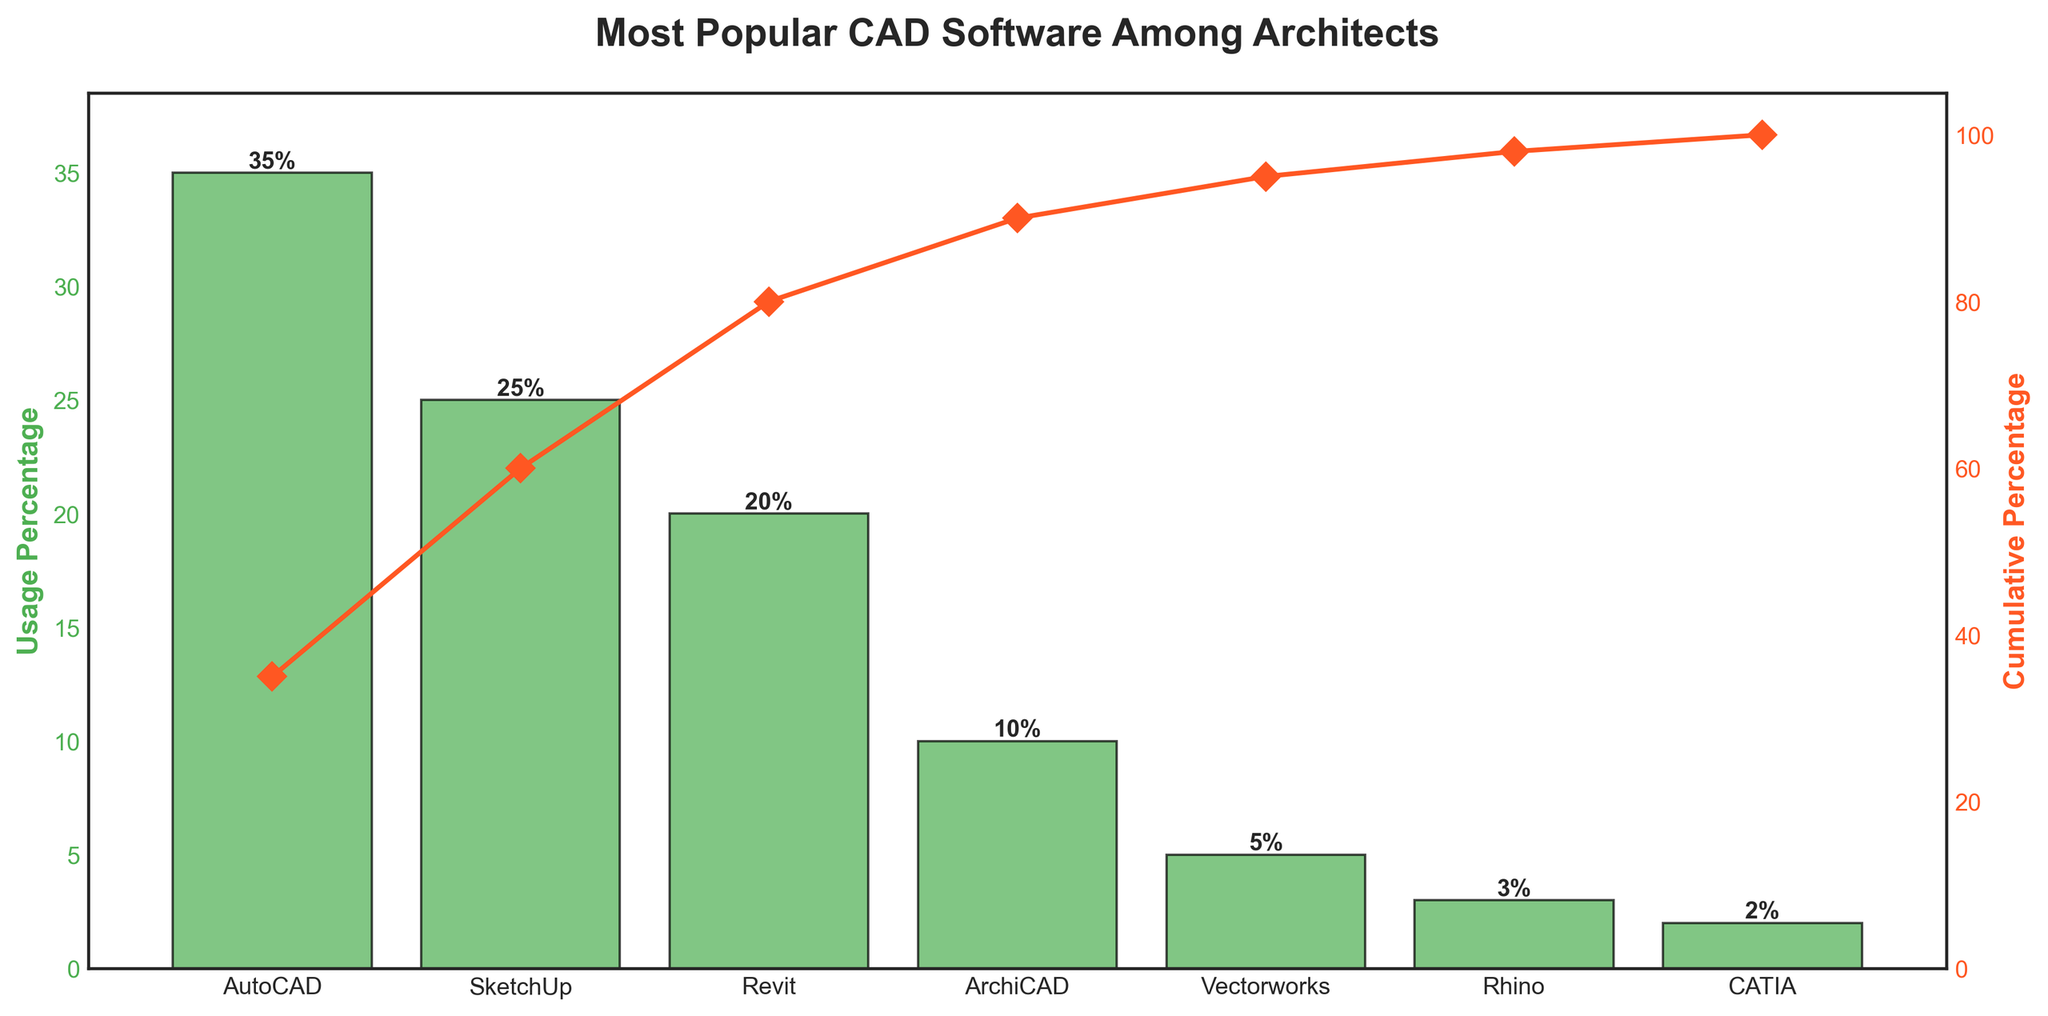what is the most popular CAD software among architects? The figure shows a Pareto chart titled 'Most Popular CAD Software Among Architects.' By looking at the primary y-axis (Usage Percentage) and the tallest bar in the chart, it is clear that AutoCAD has the highest usage percentage, which is 35%.
Answer: AutoCAD What is the combined usage percentage of the top two software? To find the combined usage percentage, add the usage percentages of AutoCAD and SketchUp. AutoCAD has 35%, and SketchUp has 25%. So, combined usage is 35% + 25% = 60%.
Answer: 60% How much more popular is AutoCAD compared to Rhino? Compare the usage percentage of AutoCAD (35%) with Rhino (3%). The difference in their usage percentages is 35% - 3% = 32%.
Answer: 32% Which software represents 50% cumulative usage? By looking at the secondary y-axis for cumulative percentage, locate the point on the cumulative percentage line closest to 50%. Revit is the software where the cumulative percentage reaches approximately 50% (35% + 25% = 60%, below it is 35% + 25% + 20% = 80%).
Answer: Revit What is the last software to appear on the cumulative percentage curve before reaching 80%? By checking the cumulative percentage line, ArchiCAD is the last software to appear just before reaching 80%. AutoCAD, SketchUp, and Revit are considered first (35% + 25% + 20% = 80%).
Answer: Revit What percentage of usage do the least popular two software have combined? Combine the usage percentages of Rhino (3%) and CATIA (2%). So, 3% + 2% = 5%.
Answer: 5% How many software systems are listed in the Pareto chart? Count the number of distinct bars in the Pareto chart. There are seven bars representing seven different software systems.
Answer: 7 Which software has the closest usage percentage to the mean usage value among all software? First, calculate the mean usage percentage: 
Mean = (35% + 25% + 20% + 10% + 5% + 3% + 2%) / 7 
Mean = 14.29%. 
Then compare the usage percentages, identifying those closest to this mean. Although none are exactly this value, ArchiCAD at 10% is closest.
Answer: ArchiCAD 